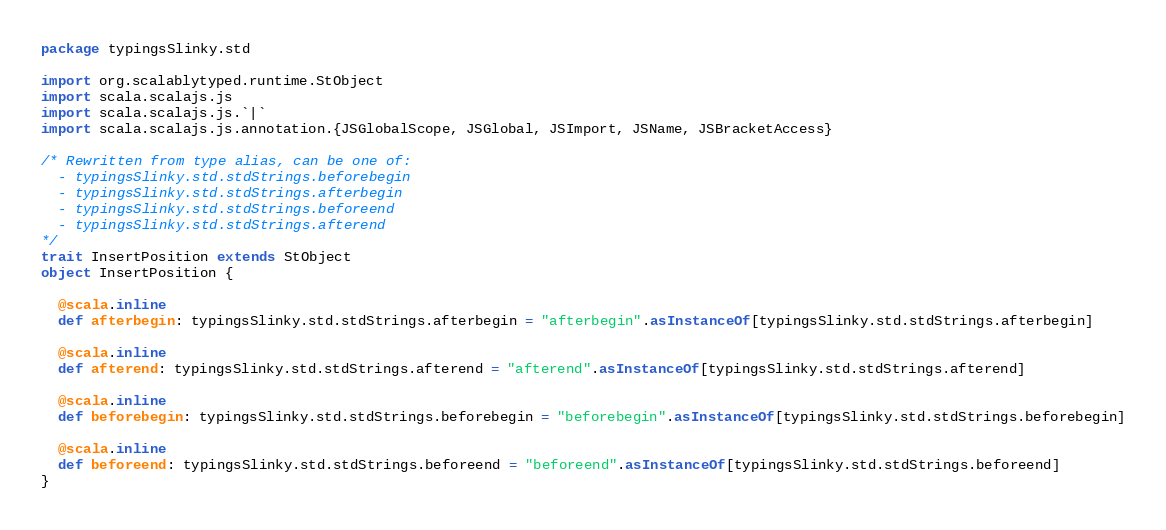Convert code to text. <code><loc_0><loc_0><loc_500><loc_500><_Scala_>package typingsSlinky.std

import org.scalablytyped.runtime.StObject
import scala.scalajs.js
import scala.scalajs.js.`|`
import scala.scalajs.js.annotation.{JSGlobalScope, JSGlobal, JSImport, JSName, JSBracketAccess}

/* Rewritten from type alias, can be one of: 
  - typingsSlinky.std.stdStrings.beforebegin
  - typingsSlinky.std.stdStrings.afterbegin
  - typingsSlinky.std.stdStrings.beforeend
  - typingsSlinky.std.stdStrings.afterend
*/
trait InsertPosition extends StObject
object InsertPosition {
  
  @scala.inline
  def afterbegin: typingsSlinky.std.stdStrings.afterbegin = "afterbegin".asInstanceOf[typingsSlinky.std.stdStrings.afterbegin]
  
  @scala.inline
  def afterend: typingsSlinky.std.stdStrings.afterend = "afterend".asInstanceOf[typingsSlinky.std.stdStrings.afterend]
  
  @scala.inline
  def beforebegin: typingsSlinky.std.stdStrings.beforebegin = "beforebegin".asInstanceOf[typingsSlinky.std.stdStrings.beforebegin]
  
  @scala.inline
  def beforeend: typingsSlinky.std.stdStrings.beforeend = "beforeend".asInstanceOf[typingsSlinky.std.stdStrings.beforeend]
}
</code> 